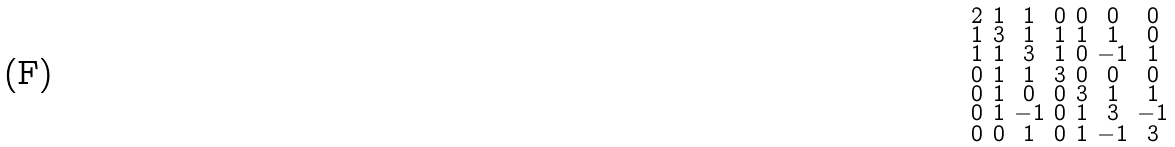<formula> <loc_0><loc_0><loc_500><loc_500>\begin{smallmatrix} 2 & 1 & 1 & 0 & 0 & 0 & 0 \\ 1 & 3 & 1 & 1 & 1 & 1 & 0 \\ 1 & 1 & 3 & 1 & 0 & - 1 & 1 \\ 0 & 1 & 1 & 3 & 0 & 0 & 0 \\ 0 & 1 & 0 & 0 & 3 & 1 & 1 \\ 0 & 1 & - 1 & 0 & 1 & 3 & - 1 \\ 0 & 0 & 1 & 0 & 1 & - 1 & 3 \end{smallmatrix}</formula> 